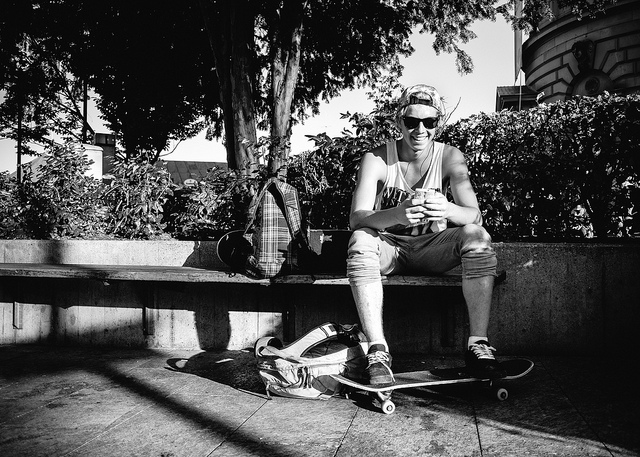<image>What year was this taken? I don't know what year was this photo taken. It can be any year from 1989 to 2012. What year was this taken? I don't know what year this was taken. It could be any of the mentioned years. 